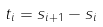Convert formula to latex. <formula><loc_0><loc_0><loc_500><loc_500>t _ { i } = s _ { i + 1 } - s _ { i }</formula> 